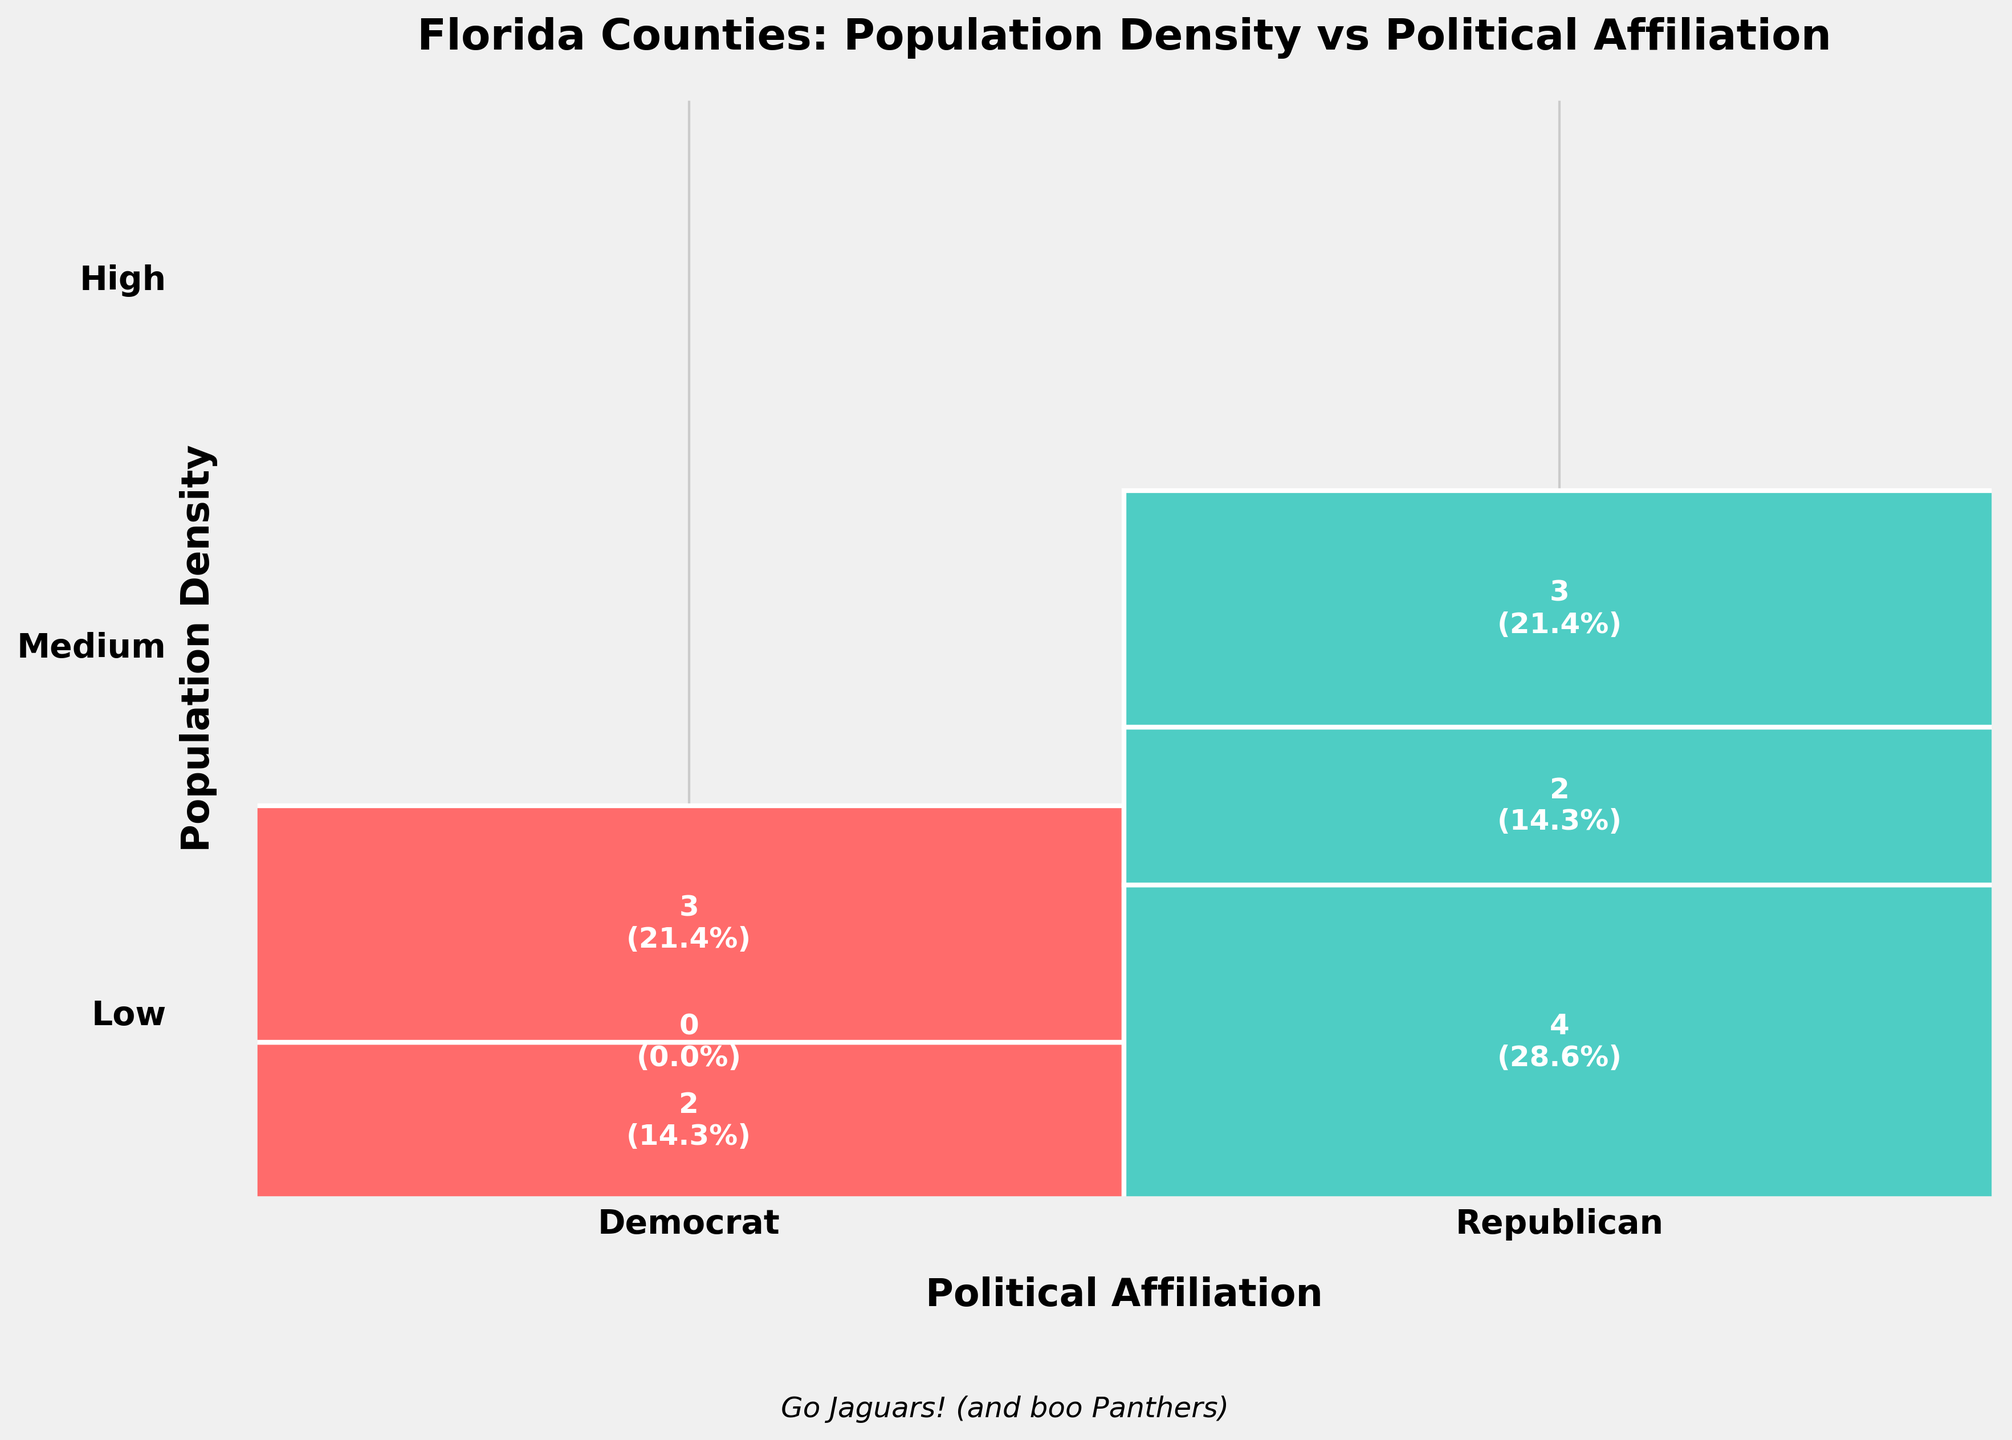What is the title of the plot? The title of the plot is located at the top and describes what the plot is showing. In this case, it reads "Florida Counties: Population Density vs Political Affiliation".
Answer: Florida Counties: Population Density vs Political Affiliation How many categories of population density are there and what are they? The plot categorizes population density into three groups, which are located on the y-axis labels. They are 'Low', 'Medium', and 'High'.
Answer: 3 categories: Low, Medium, High Which political affiliation has more counties in the 'High' population density category? By looking at the 'High' population density section, we compare the two colored areas corresponding to Democrat and Republican. The larger area belongs to Democrat, indicating more counties.
Answer: Democrat How many counties have 'Medium' population density and are Republican-affiliated? In the 'Medium' population density section, there is one segment corresponding to Republican counties. By observing, we see there are 2 counties shown in this area.
Answer: 2 What percentage of counties in the 'Low' population density category are Democrat-affiliated? For this, we examine the 'Low' population density category and look at the area corresponding to Democrat by checking the text inside the segment. It shows 2 counties, which we calculate as a percentage of the total in this category (5). So, (2/5) * 100% = 40%.
Answer: 40% Which political affiliation has the larger total number of counties across all population densities? Summing up the areas dedicated to each political affiliation across all categories shows the total number of counties. Republicans have 8 and Democrats have 6.
Answer: Republican How many total counties are represented in the plot? Adding up the numbers from each segment in the plot: 5 (Low) + 2 (Medium) + 3 (High) = 10 pro counties for each party, resulting in a total of 14 counties displayed in the plot.
Answer: 14 In which population density category is the distribution of political affiliations most balanced? Balance means the sizes of the two segments (Republican and Democrat) are closer to being equal. In the 'Medium' category, both affiliations have nearly equal areas, implying a balanced distribution.
Answer: Medium 